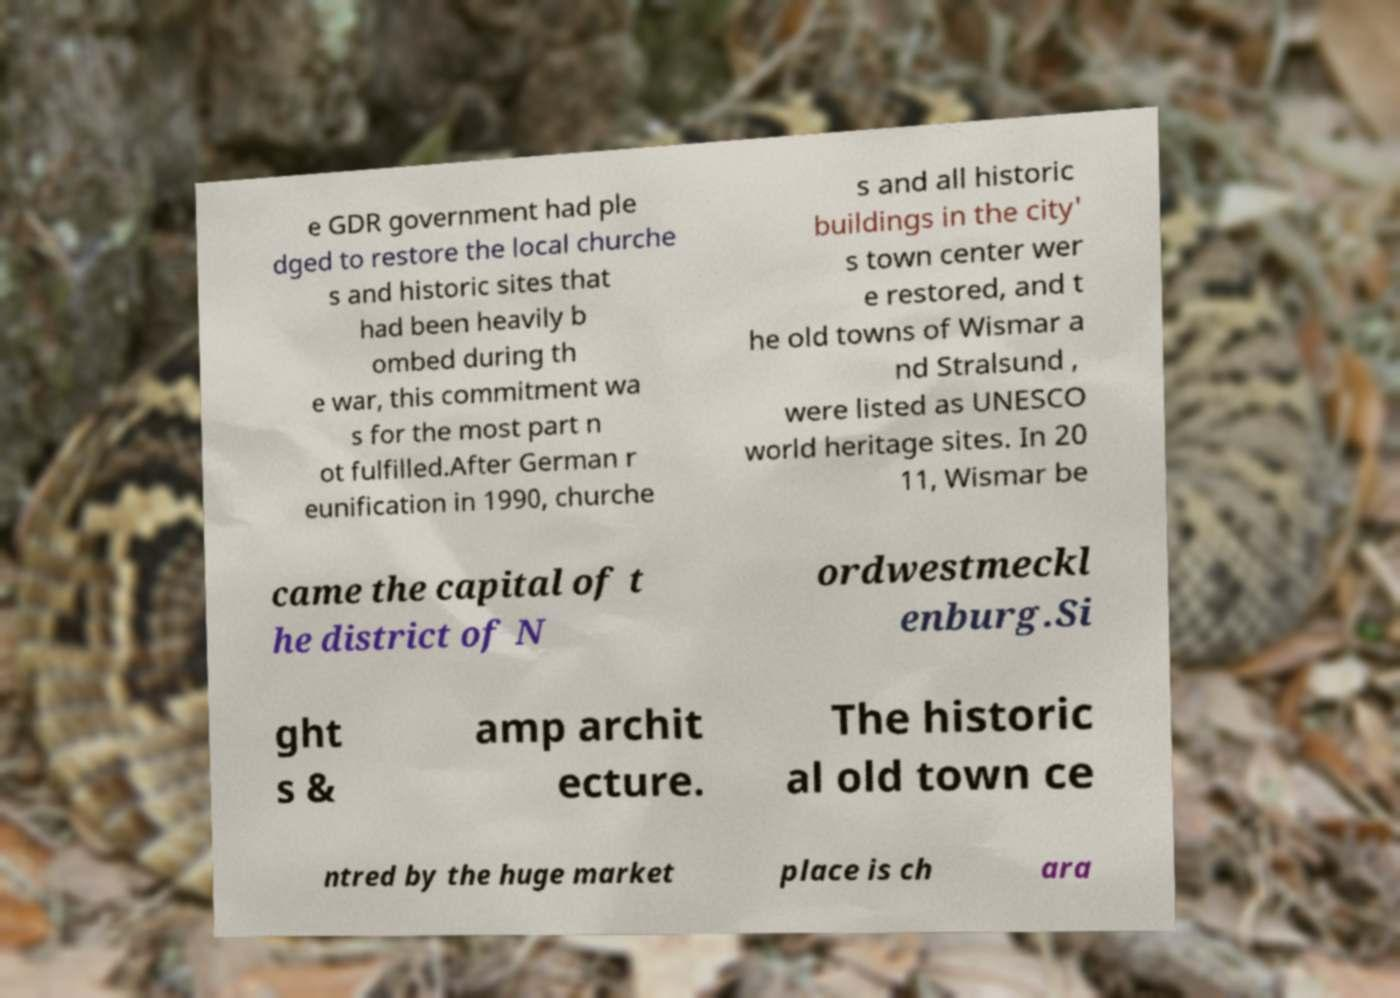Please read and relay the text visible in this image. What does it say? e GDR government had ple dged to restore the local churche s and historic sites that had been heavily b ombed during th e war, this commitment wa s for the most part n ot fulfilled.After German r eunification in 1990, churche s and all historic buildings in the city' s town center wer e restored, and t he old towns of Wismar a nd Stralsund , were listed as UNESCO world heritage sites. In 20 11, Wismar be came the capital of t he district of N ordwestmeckl enburg.Si ght s & amp archit ecture. The historic al old town ce ntred by the huge market place is ch ara 